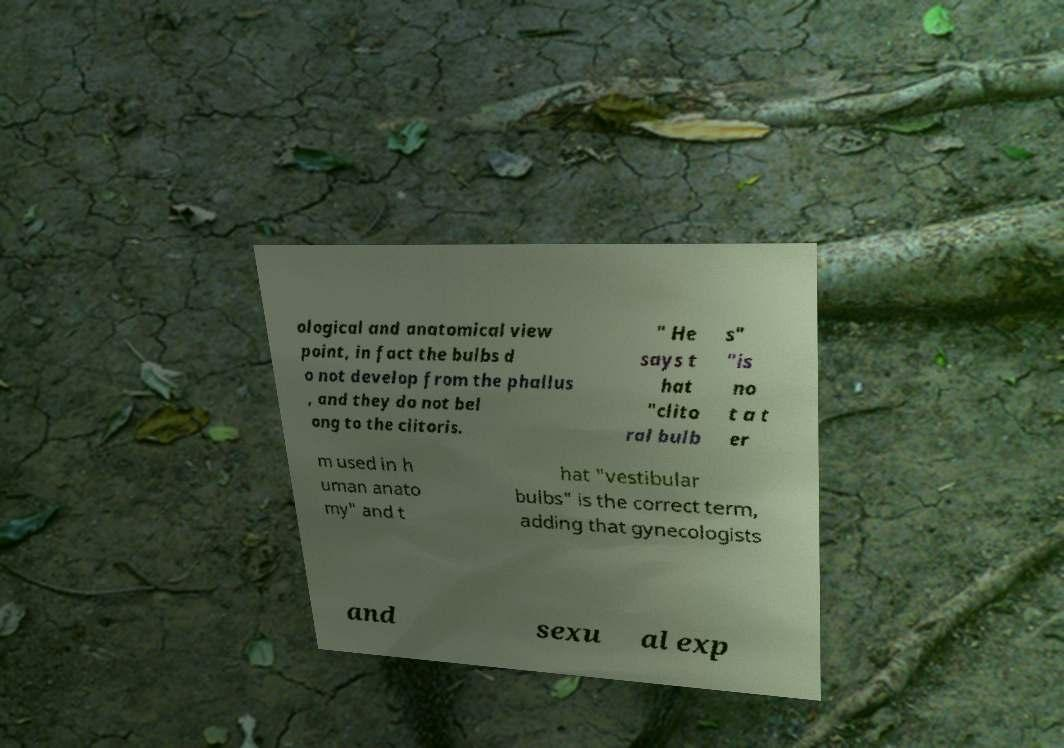Please identify and transcribe the text found in this image. ological and anatomical view point, in fact the bulbs d o not develop from the phallus , and they do not bel ong to the clitoris. " He says t hat "clito ral bulb s" "is no t a t er m used in h uman anato my" and t hat "vestibular bulbs" is the correct term, adding that gynecologists and sexu al exp 